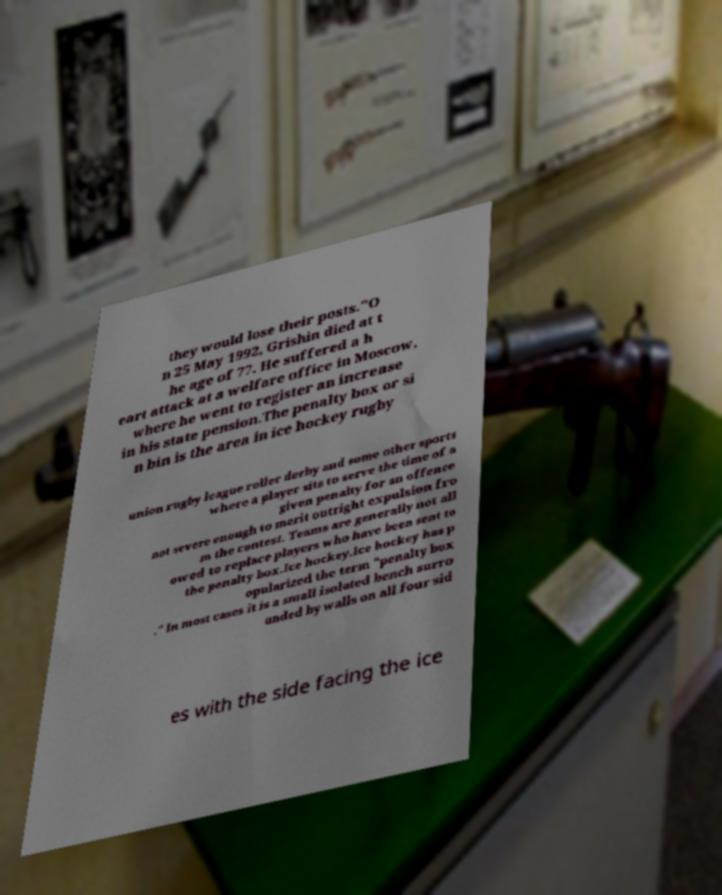Please identify and transcribe the text found in this image. they would lose their posts."O n 25 May 1992, Grishin died at t he age of 77. He suffered a h eart attack at a welfare office in Moscow, where he went to register an increase in his state pension.The penalty box or si n bin is the area in ice hockey rugby union rugby league roller derby and some other sports where a player sits to serve the time of a given penalty for an offence not severe enough to merit outright expulsion fro m the contest. Teams are generally not all owed to replace players who have been sent to the penalty box.Ice hockey.Ice hockey has p opularized the term "penalty box ." In most cases it is a small isolated bench surro unded by walls on all four sid es with the side facing the ice 